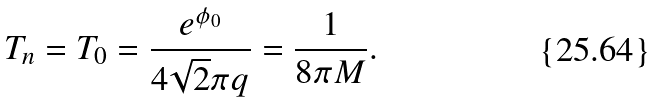Convert formula to latex. <formula><loc_0><loc_0><loc_500><loc_500>T _ { n } = T _ { 0 } = \frac { e ^ { \phi _ { 0 } } } { 4 \sqrt { 2 } \pi q } = \frac { 1 } { 8 \pi M } .</formula> 